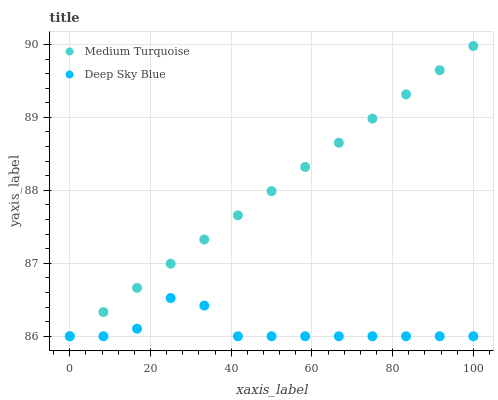Does Deep Sky Blue have the minimum area under the curve?
Answer yes or no. Yes. Does Medium Turquoise have the maximum area under the curve?
Answer yes or no. Yes. Does Medium Turquoise have the minimum area under the curve?
Answer yes or no. No. Is Medium Turquoise the smoothest?
Answer yes or no. Yes. Is Deep Sky Blue the roughest?
Answer yes or no. Yes. Is Medium Turquoise the roughest?
Answer yes or no. No. Does Deep Sky Blue have the lowest value?
Answer yes or no. Yes. Does Medium Turquoise have the highest value?
Answer yes or no. Yes. Does Medium Turquoise intersect Deep Sky Blue?
Answer yes or no. Yes. Is Medium Turquoise less than Deep Sky Blue?
Answer yes or no. No. Is Medium Turquoise greater than Deep Sky Blue?
Answer yes or no. No. 